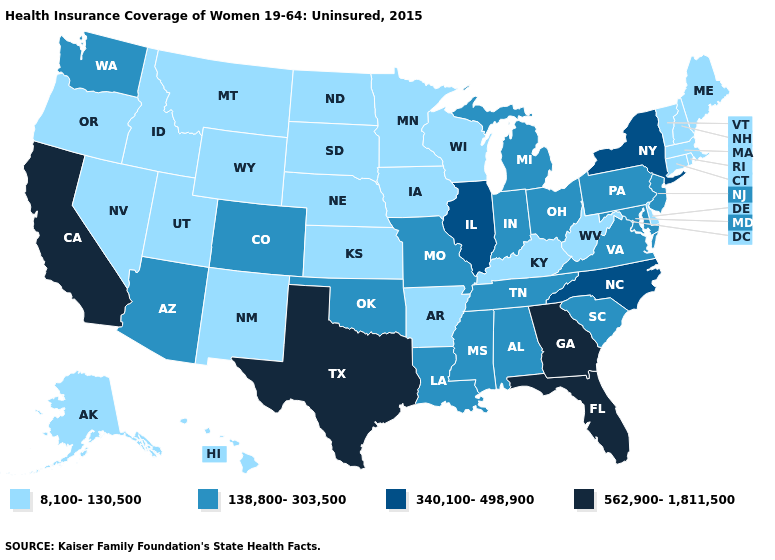What is the value of Florida?
Concise answer only. 562,900-1,811,500. Does Vermont have the lowest value in the USA?
Concise answer only. Yes. Name the states that have a value in the range 562,900-1,811,500?
Quick response, please. California, Florida, Georgia, Texas. What is the highest value in states that border Ohio?
Answer briefly. 138,800-303,500. What is the highest value in the USA?
Write a very short answer. 562,900-1,811,500. What is the value of North Carolina?
Keep it brief. 340,100-498,900. Does the map have missing data?
Be succinct. No. What is the value of North Dakota?
Be succinct. 8,100-130,500. Name the states that have a value in the range 562,900-1,811,500?
Short answer required. California, Florida, Georgia, Texas. Does California have the lowest value in the West?
Concise answer only. No. Does South Carolina have the lowest value in the USA?
Quick response, please. No. What is the lowest value in the West?
Write a very short answer. 8,100-130,500. Does the map have missing data?
Write a very short answer. No. Which states have the highest value in the USA?
Be succinct. California, Florida, Georgia, Texas. 